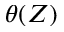Convert formula to latex. <formula><loc_0><loc_0><loc_500><loc_500>\theta ( Z )</formula> 